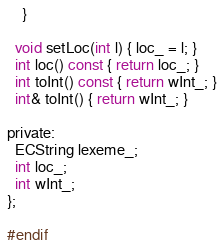<code> <loc_0><loc_0><loc_500><loc_500><_C_>    }

  void setLoc(int l) { loc_ = l; }
  int loc() const { return loc_; }
  int toInt() const { return wInt_; }
  int& toInt() { return wInt_; }

private:
  ECString lexeme_;
  int loc_;
  int wInt_;
};

#endif
</code> 